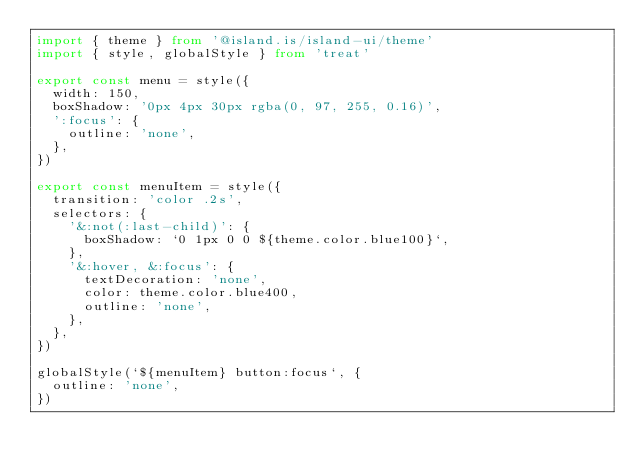Convert code to text. <code><loc_0><loc_0><loc_500><loc_500><_TypeScript_>import { theme } from '@island.is/island-ui/theme'
import { style, globalStyle } from 'treat'

export const menu = style({
  width: 150,
  boxShadow: '0px 4px 30px rgba(0, 97, 255, 0.16)',
  ':focus': {
    outline: 'none',
  },
})

export const menuItem = style({
  transition: 'color .2s',
  selectors: {
    '&:not(:last-child)': {
      boxShadow: `0 1px 0 0 ${theme.color.blue100}`,
    },
    '&:hover, &:focus': {
      textDecoration: 'none',
      color: theme.color.blue400,
      outline: 'none',
    },
  },
})

globalStyle(`${menuItem} button:focus`, {
  outline: 'none',
})
</code> 